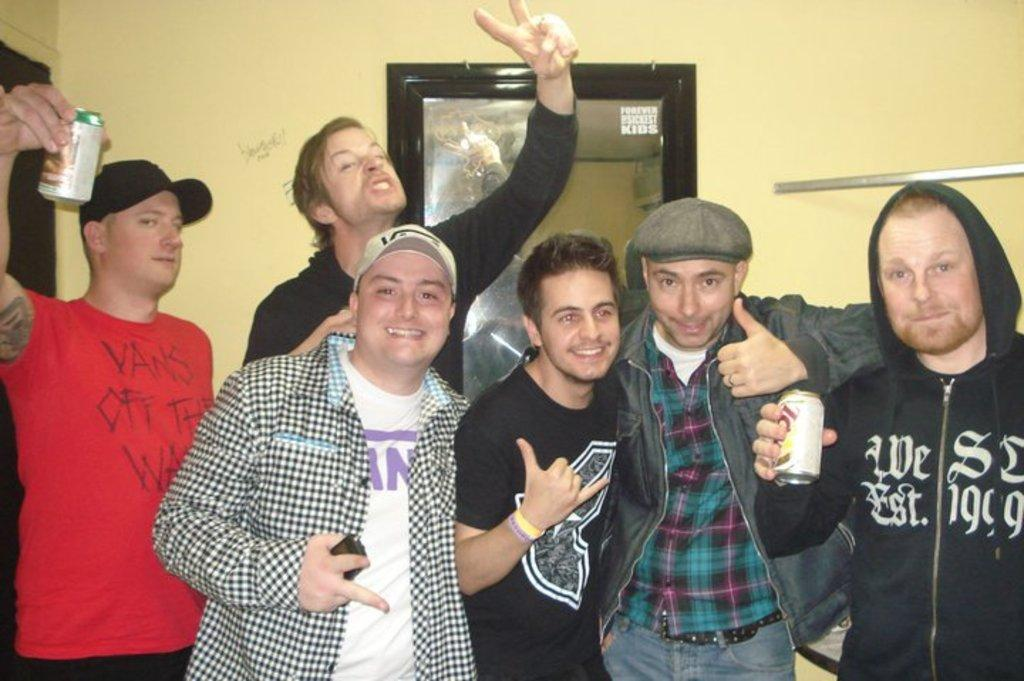<image>
Create a compact narrative representing the image presented. A group of friends are drinking and one has a hoodie with the year 1999 on it. 